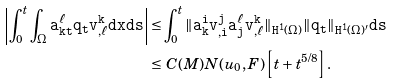<formula> <loc_0><loc_0><loc_500><loc_500>\left | \int _ { 0 } ^ { t } \int _ { \Omega } \tt a _ { k t } ^ { \ell } q _ { t } v ^ { k } _ { , \ell } d x d s \right | \leq & \int _ { 0 } ^ { t } \| \tt a _ { k } ^ { i } \tt v _ { , i } ^ { j } \tt a _ { j } ^ { \ell } v ^ { k } _ { , \ell } \| _ { H ^ { 1 } ( \Omega ) } \| q _ { t } \| _ { H ^ { 1 } ( \Omega ) ^ { \prime } } d s \\ \leq & \ C ( M ) N ( u _ { 0 } , F ) \left [ t + t ^ { 5 / 8 } \right ] .</formula> 